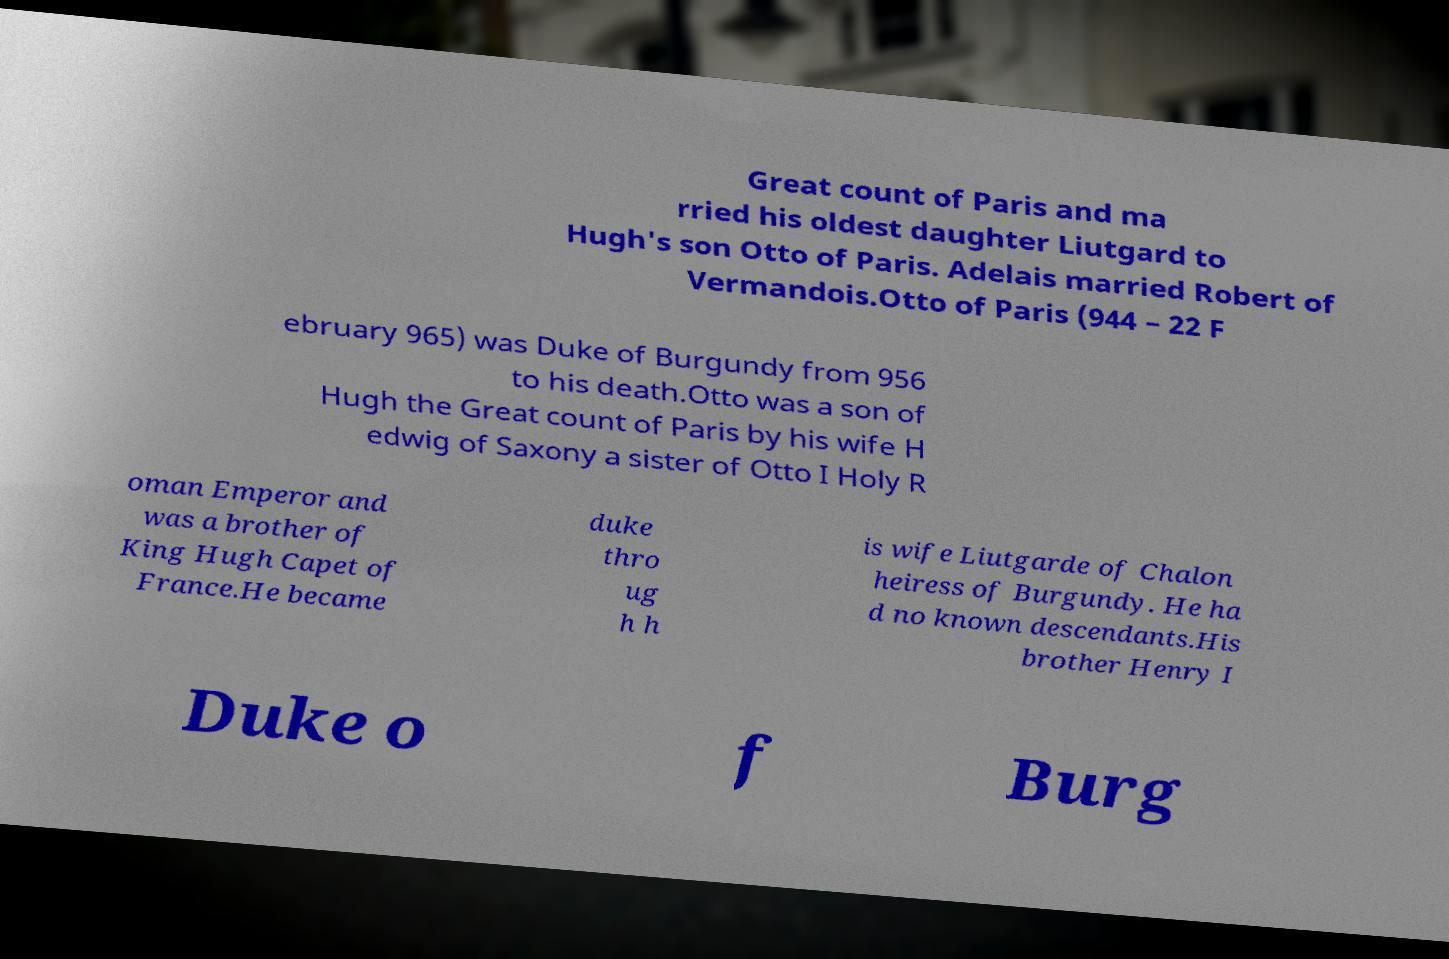For documentation purposes, I need the text within this image transcribed. Could you provide that? Great count of Paris and ma rried his oldest daughter Liutgard to Hugh's son Otto of Paris. Adelais married Robert of Vermandois.Otto of Paris (944 – 22 F ebruary 965) was Duke of Burgundy from 956 to his death.Otto was a son of Hugh the Great count of Paris by his wife H edwig of Saxony a sister of Otto I Holy R oman Emperor and was a brother of King Hugh Capet of France.He became duke thro ug h h is wife Liutgarde of Chalon heiress of Burgundy. He ha d no known descendants.His brother Henry I Duke o f Burg 